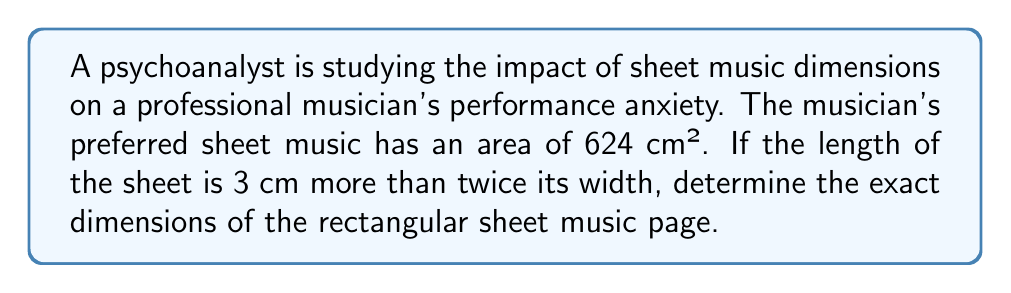Show me your answer to this math problem. Let's approach this step-by-step:

1) Let $w$ represent the width of the sheet music.
2) The length is 3 cm more than twice the width, so we can express it as $2w + 3$.
3) The area of a rectangle is given by length × width. So we can write:

   $$w(2w + 3) = 624$$

4) Expand the equation:

   $$2w^2 + 3w = 624$$

5) Rearrange to standard quadratic form:

   $$2w^2 + 3w - 624 = 0$$

6) Use the quadratic formula: $w = \frac{-b \pm \sqrt{b^2 - 4ac}}{2a}$

   Where $a = 2$, $b = 3$, and $c = -624$

7) Substitute these values:

   $$w = \frac{-3 \pm \sqrt{3^2 - 4(2)(-624)}}{2(2)}$$

8) Simplify:

   $$w = \frac{-3 \pm \sqrt{9 + 4992}}{4} = \frac{-3 \pm \sqrt{5001}}{4}$$

9) Solve:

   $$w = \frac{-3 + \sqrt{5001}}{4} \approx 17.25$$

   (We discard the negative solution as width cannot be negative)

10) Round to the nearest centimeter: $w = 17$ cm

11) Calculate the length: $2w + 3 = 2(17) + 3 = 37$ cm

Therefore, the dimensions of the sheet music are 17 cm × 37 cm.
Answer: 17 cm × 37 cm 